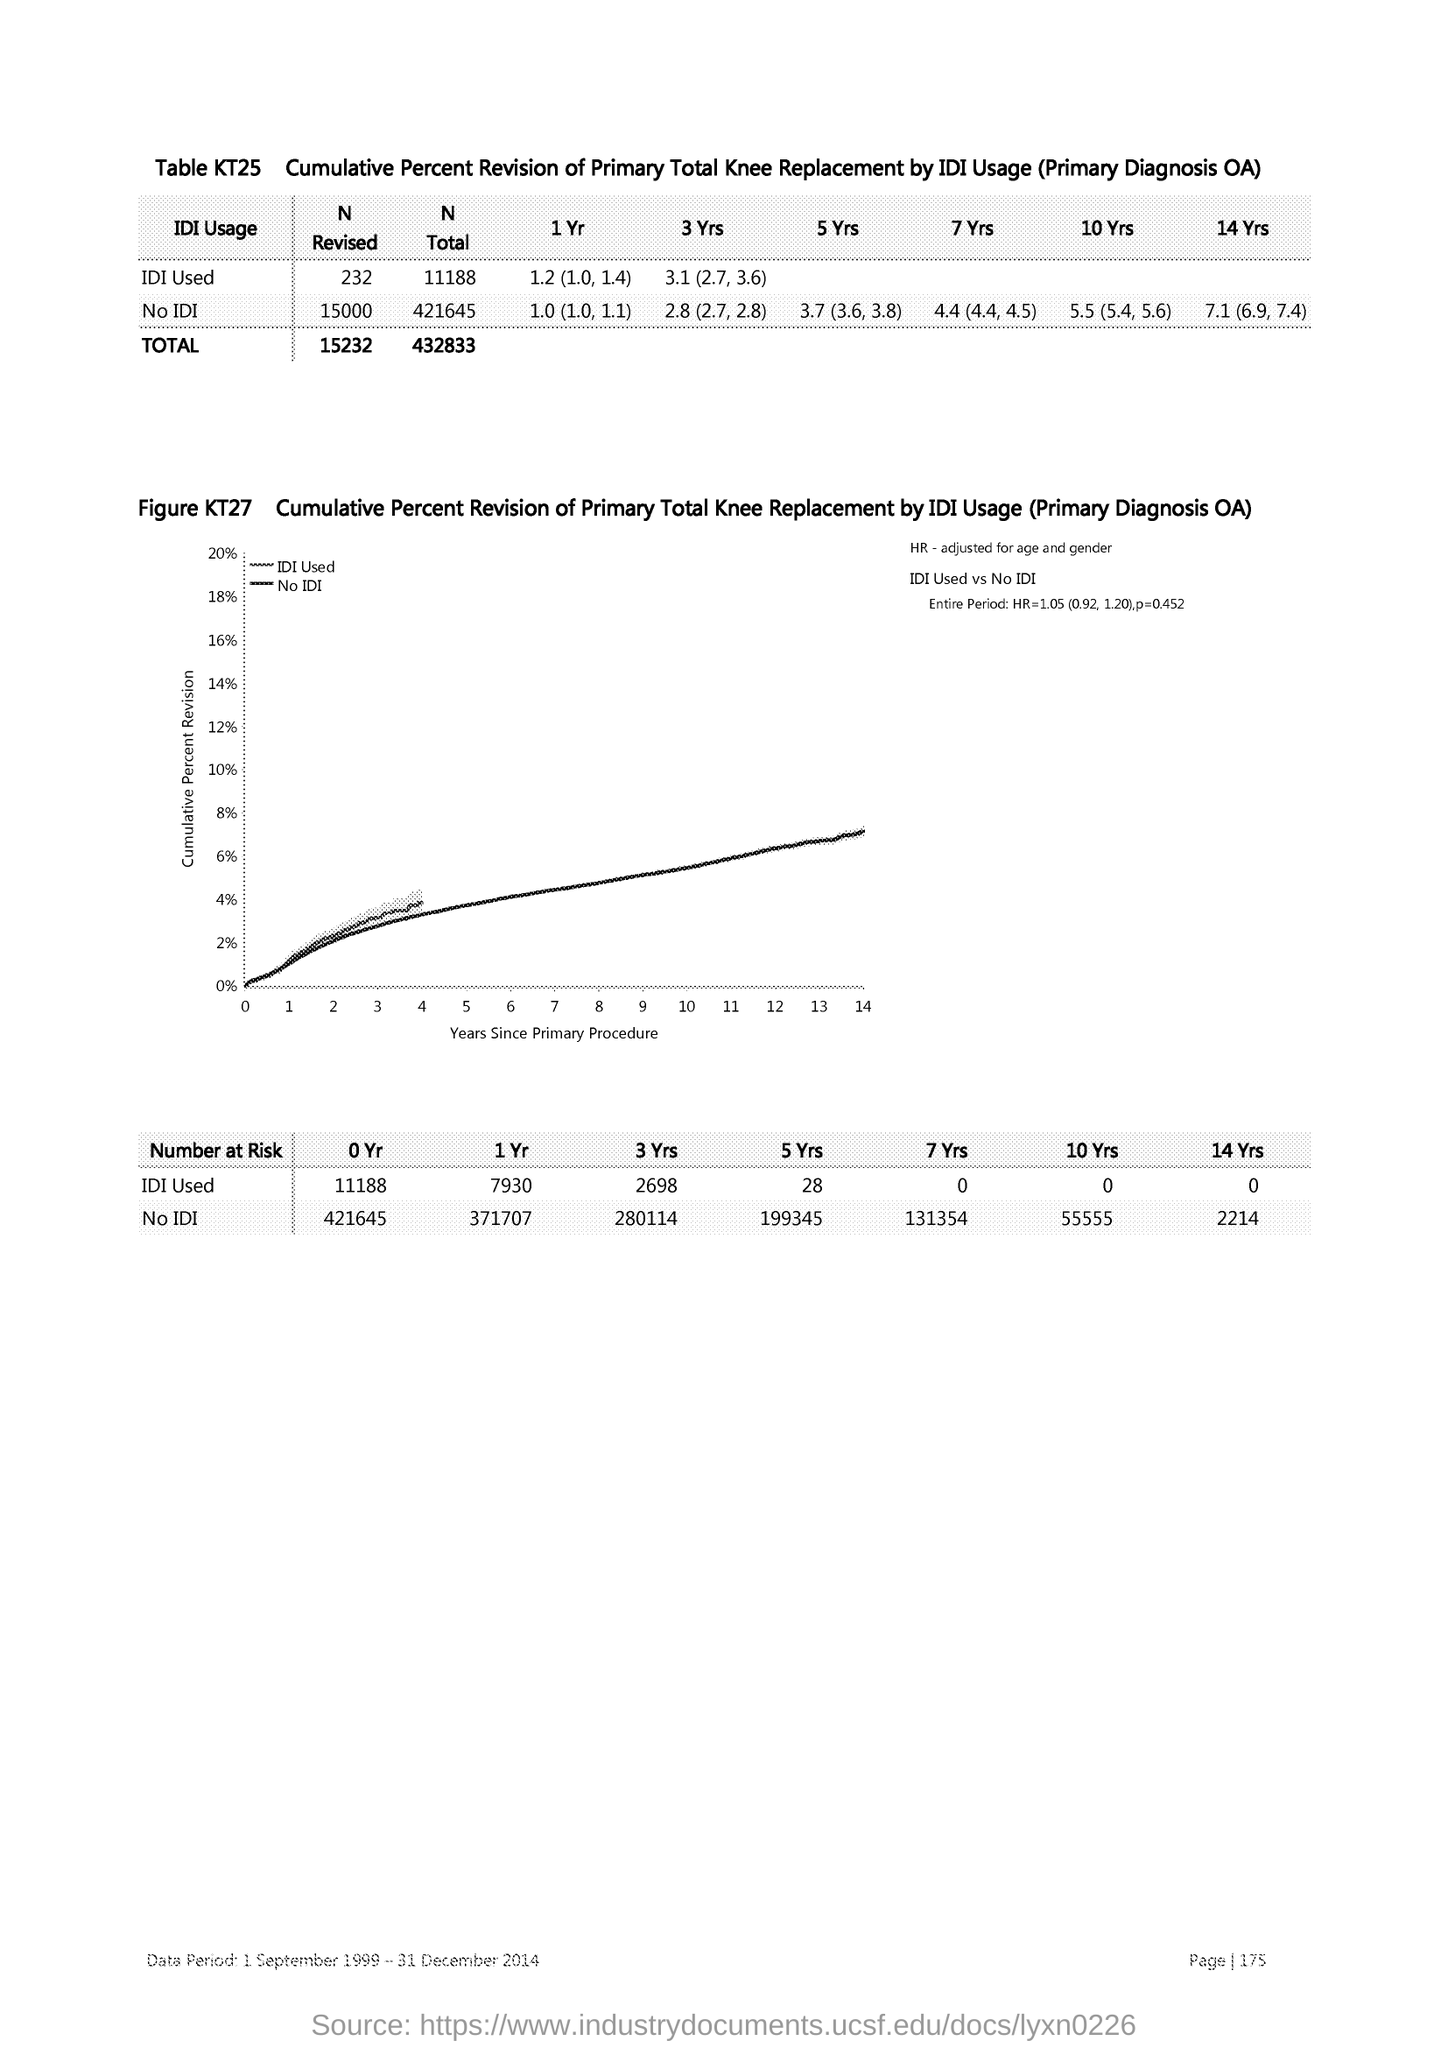What is plotted in the y-axis?
Ensure brevity in your answer.  Cumulative Percent Revision. What is plotted in the x-axis?
Keep it short and to the point. Years since Primary Procedure. 